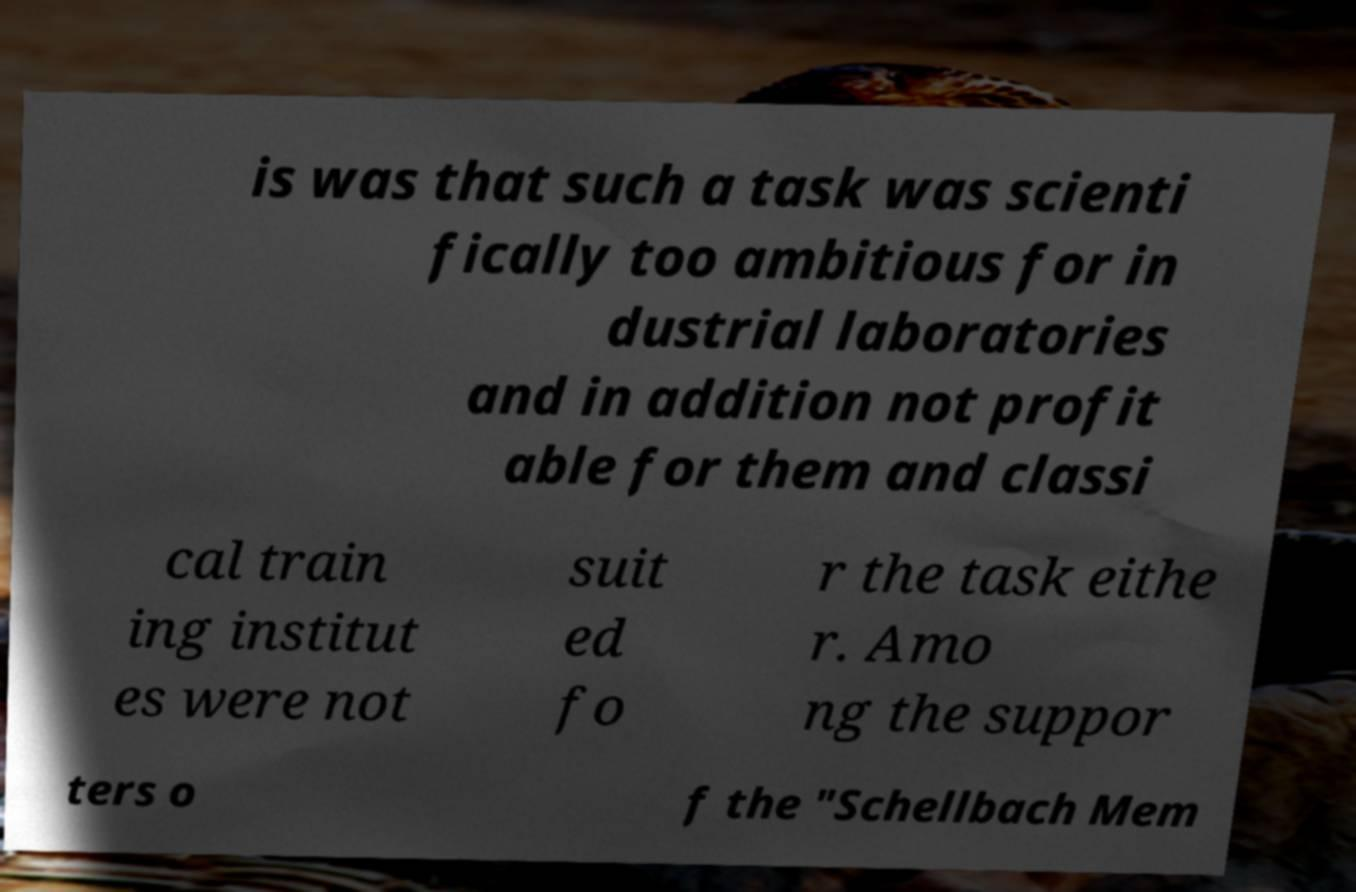Could you extract and type out the text from this image? is was that such a task was scienti fically too ambitious for in dustrial laboratories and in addition not profit able for them and classi cal train ing institut es were not suit ed fo r the task eithe r. Amo ng the suppor ters o f the "Schellbach Mem 